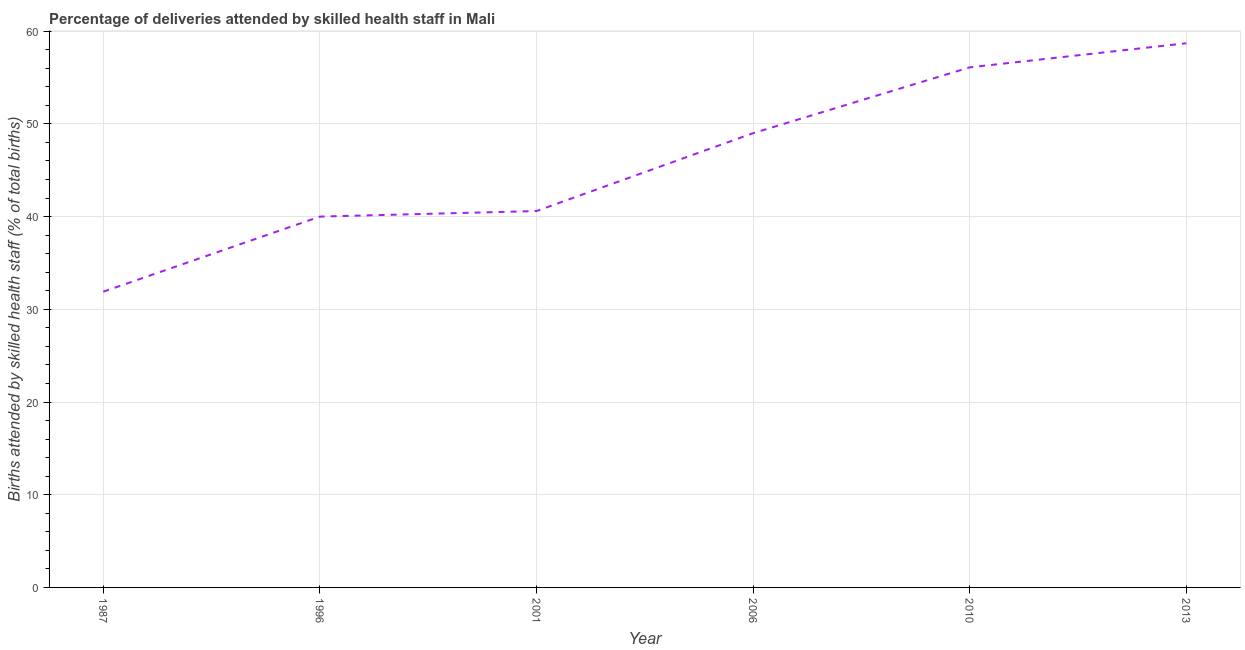What is the number of births attended by skilled health staff in 2001?
Provide a short and direct response. 40.6. Across all years, what is the maximum number of births attended by skilled health staff?
Your response must be concise. 58.7. Across all years, what is the minimum number of births attended by skilled health staff?
Ensure brevity in your answer.  31.9. What is the sum of the number of births attended by skilled health staff?
Your response must be concise. 276.3. What is the difference between the number of births attended by skilled health staff in 2006 and 2010?
Your response must be concise. -7.1. What is the average number of births attended by skilled health staff per year?
Your answer should be very brief. 46.05. What is the median number of births attended by skilled health staff?
Your response must be concise. 44.8. Do a majority of the years between 2013 and 2010 (inclusive) have number of births attended by skilled health staff greater than 36 %?
Provide a succinct answer. No. What is the ratio of the number of births attended by skilled health staff in 2006 to that in 2010?
Give a very brief answer. 0.87. Is the difference between the number of births attended by skilled health staff in 2006 and 2010 greater than the difference between any two years?
Offer a terse response. No. What is the difference between the highest and the second highest number of births attended by skilled health staff?
Provide a succinct answer. 2.6. Is the sum of the number of births attended by skilled health staff in 2001 and 2013 greater than the maximum number of births attended by skilled health staff across all years?
Offer a terse response. Yes. What is the difference between the highest and the lowest number of births attended by skilled health staff?
Give a very brief answer. 26.8. Does the number of births attended by skilled health staff monotonically increase over the years?
Provide a succinct answer. Yes. How many lines are there?
Your answer should be very brief. 1. How many years are there in the graph?
Provide a succinct answer. 6. What is the difference between two consecutive major ticks on the Y-axis?
Give a very brief answer. 10. Are the values on the major ticks of Y-axis written in scientific E-notation?
Provide a succinct answer. No. Does the graph contain any zero values?
Keep it short and to the point. No. What is the title of the graph?
Offer a terse response. Percentage of deliveries attended by skilled health staff in Mali. What is the label or title of the Y-axis?
Your answer should be very brief. Births attended by skilled health staff (% of total births). What is the Births attended by skilled health staff (% of total births) of 1987?
Your answer should be very brief. 31.9. What is the Births attended by skilled health staff (% of total births) in 1996?
Offer a terse response. 40. What is the Births attended by skilled health staff (% of total births) in 2001?
Keep it short and to the point. 40.6. What is the Births attended by skilled health staff (% of total births) of 2006?
Your answer should be very brief. 49. What is the Births attended by skilled health staff (% of total births) in 2010?
Offer a terse response. 56.1. What is the Births attended by skilled health staff (% of total births) in 2013?
Give a very brief answer. 58.7. What is the difference between the Births attended by skilled health staff (% of total births) in 1987 and 1996?
Your answer should be very brief. -8.1. What is the difference between the Births attended by skilled health staff (% of total births) in 1987 and 2006?
Your answer should be very brief. -17.1. What is the difference between the Births attended by skilled health staff (% of total births) in 1987 and 2010?
Offer a very short reply. -24.2. What is the difference between the Births attended by skilled health staff (% of total births) in 1987 and 2013?
Provide a short and direct response. -26.8. What is the difference between the Births attended by skilled health staff (% of total births) in 1996 and 2001?
Your response must be concise. -0.6. What is the difference between the Births attended by skilled health staff (% of total births) in 1996 and 2006?
Provide a succinct answer. -9. What is the difference between the Births attended by skilled health staff (% of total births) in 1996 and 2010?
Make the answer very short. -16.1. What is the difference between the Births attended by skilled health staff (% of total births) in 1996 and 2013?
Keep it short and to the point. -18.7. What is the difference between the Births attended by skilled health staff (% of total births) in 2001 and 2010?
Give a very brief answer. -15.5. What is the difference between the Births attended by skilled health staff (% of total births) in 2001 and 2013?
Ensure brevity in your answer.  -18.1. What is the difference between the Births attended by skilled health staff (% of total births) in 2006 and 2013?
Provide a succinct answer. -9.7. What is the difference between the Births attended by skilled health staff (% of total births) in 2010 and 2013?
Ensure brevity in your answer.  -2.6. What is the ratio of the Births attended by skilled health staff (% of total births) in 1987 to that in 1996?
Provide a short and direct response. 0.8. What is the ratio of the Births attended by skilled health staff (% of total births) in 1987 to that in 2001?
Offer a terse response. 0.79. What is the ratio of the Births attended by skilled health staff (% of total births) in 1987 to that in 2006?
Keep it short and to the point. 0.65. What is the ratio of the Births attended by skilled health staff (% of total births) in 1987 to that in 2010?
Keep it short and to the point. 0.57. What is the ratio of the Births attended by skilled health staff (% of total births) in 1987 to that in 2013?
Make the answer very short. 0.54. What is the ratio of the Births attended by skilled health staff (% of total births) in 1996 to that in 2001?
Ensure brevity in your answer.  0.98. What is the ratio of the Births attended by skilled health staff (% of total births) in 1996 to that in 2006?
Your response must be concise. 0.82. What is the ratio of the Births attended by skilled health staff (% of total births) in 1996 to that in 2010?
Offer a terse response. 0.71. What is the ratio of the Births attended by skilled health staff (% of total births) in 1996 to that in 2013?
Make the answer very short. 0.68. What is the ratio of the Births attended by skilled health staff (% of total births) in 2001 to that in 2006?
Ensure brevity in your answer.  0.83. What is the ratio of the Births attended by skilled health staff (% of total births) in 2001 to that in 2010?
Your answer should be compact. 0.72. What is the ratio of the Births attended by skilled health staff (% of total births) in 2001 to that in 2013?
Ensure brevity in your answer.  0.69. What is the ratio of the Births attended by skilled health staff (% of total births) in 2006 to that in 2010?
Ensure brevity in your answer.  0.87. What is the ratio of the Births attended by skilled health staff (% of total births) in 2006 to that in 2013?
Your answer should be compact. 0.83. What is the ratio of the Births attended by skilled health staff (% of total births) in 2010 to that in 2013?
Make the answer very short. 0.96. 